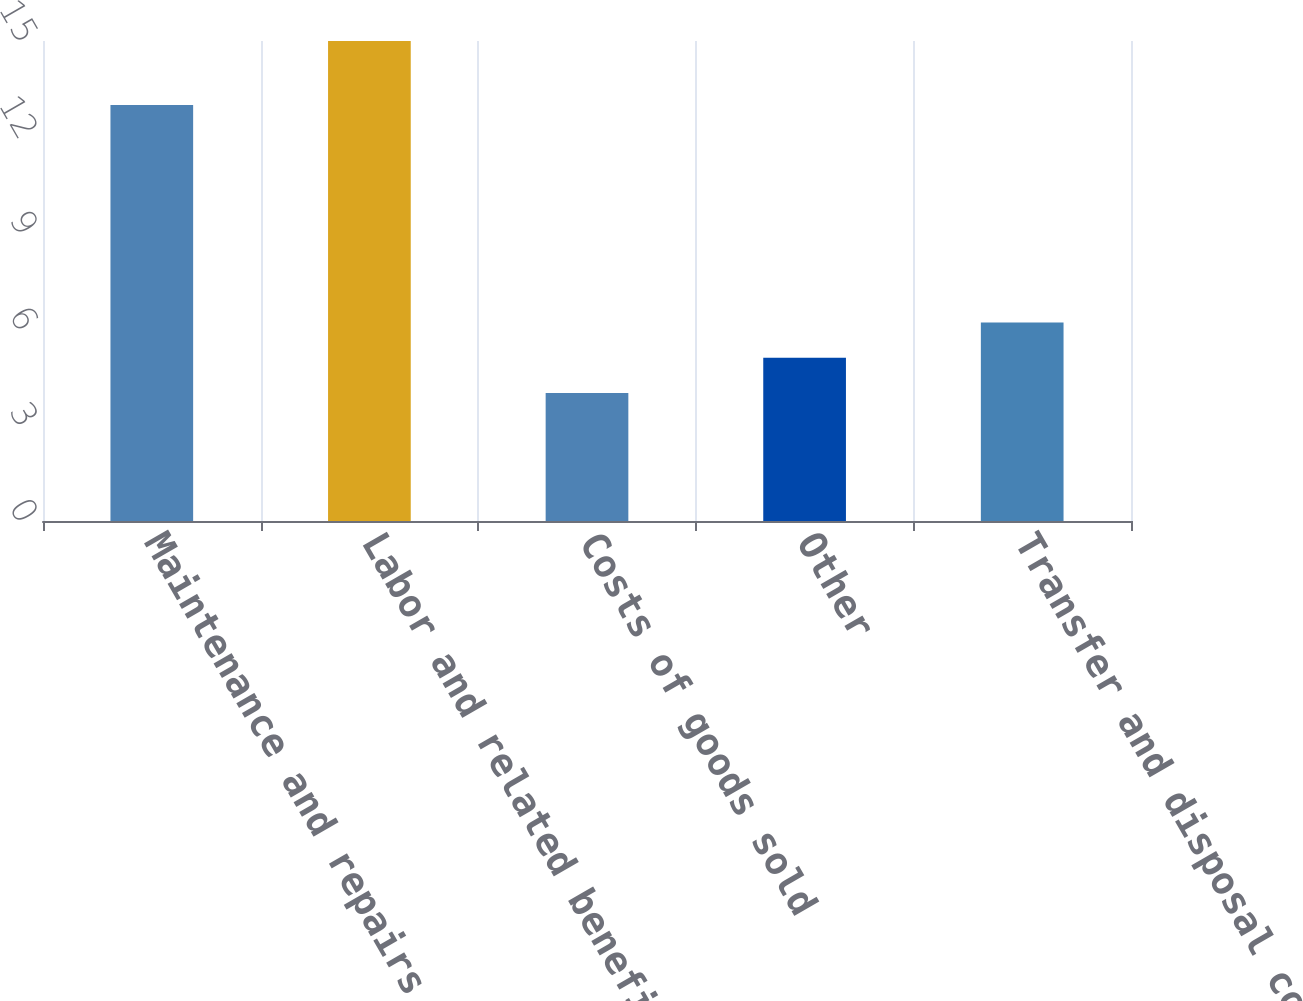<chart> <loc_0><loc_0><loc_500><loc_500><bar_chart><fcel>Maintenance and repairs<fcel>Labor and related benefits<fcel>Costs of goods sold<fcel>Other<fcel>Transfer and disposal cost<nl><fcel>13<fcel>15<fcel>4<fcel>5.1<fcel>6.2<nl></chart> 